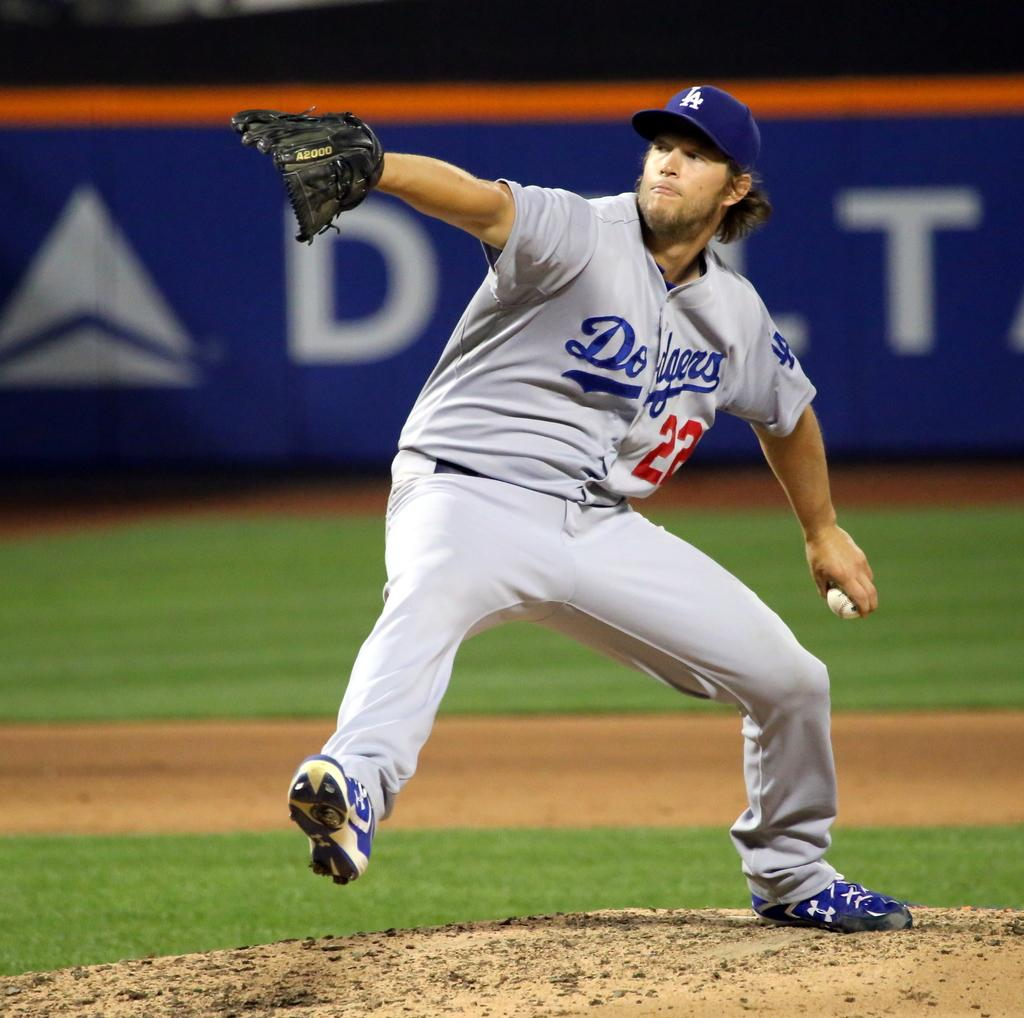What can be seen in the image? There is a person in the image. What is the person wearing on their hands and head? The person is wearing gloves and a hat. What is the person holding in their hand? The person is holding something, but we cannot determine what it is from the image. What else is visible in the image? There is a poster visible in the image. What type of thunder can be heard in the image? There is no sound present in the image, so we cannot determine if thunder can be heard. 